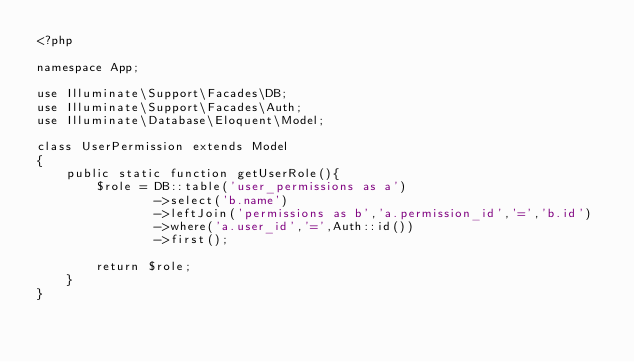Convert code to text. <code><loc_0><loc_0><loc_500><loc_500><_PHP_><?php

namespace App;

use Illuminate\Support\Facades\DB;
use Illuminate\Support\Facades\Auth;
use Illuminate\Database\Eloquent\Model;

class UserPermission extends Model
{
    public static function getUserRole(){
    	$role = DB::table('user_permissions as a')
    			->select('b.name')
    			->leftJoin('permissions as b','a.permission_id','=','b.id')
    			->where('a.user_id','=',Auth::id())
    			->first();

		return $role;
    }
}
</code> 